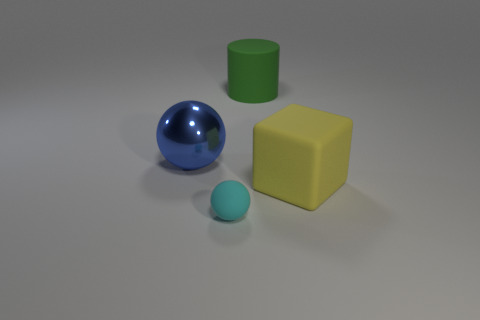Is there any other thing that is the same size as the cyan sphere?
Your answer should be very brief. No. What number of tiny cyan matte balls are there?
Provide a succinct answer. 1. What shape is the large thing that is both on the right side of the blue metallic object and behind the big block?
Ensure brevity in your answer.  Cylinder. What shape is the matte thing that is in front of the large rubber object that is to the right of the big thing behind the big blue metal object?
Offer a very short reply. Sphere. There is a large thing that is both in front of the big green rubber object and left of the yellow matte thing; what is its material?
Keep it short and to the point. Metal. How many other matte balls are the same size as the cyan ball?
Your answer should be very brief. 0. What number of shiny things are large cyan things or cyan balls?
Ensure brevity in your answer.  0. What is the cyan object made of?
Your response must be concise. Rubber. What number of blue balls are to the left of the cyan ball?
Provide a short and direct response. 1. Is the material of the sphere behind the small rubber sphere the same as the large yellow thing?
Your answer should be very brief. No. 